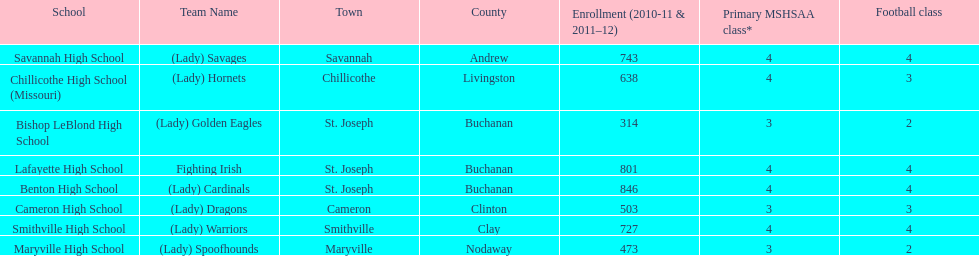How many of the schools had at least 500 students enrolled in the 2010-2011 and 2011-2012 season? 6. 